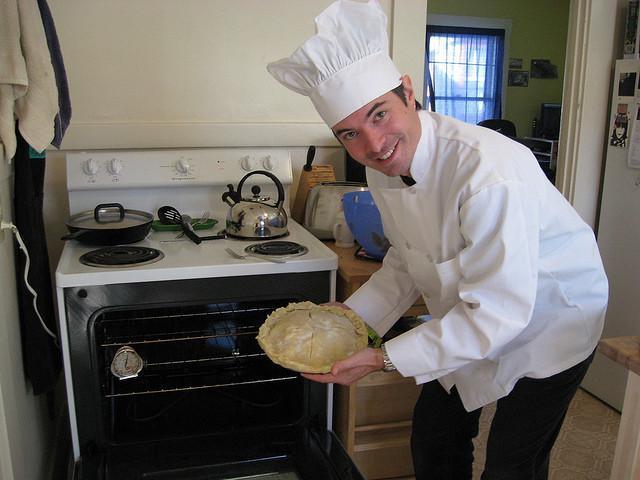How many chefs are in the kitchen?
Give a very brief answer. 1. How many teddy bears are wearing a hair bow?
Give a very brief answer. 0. 